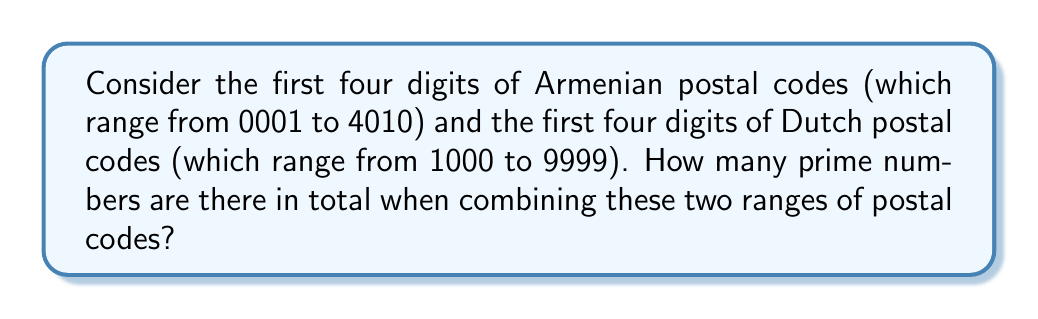Provide a solution to this math problem. Let's approach this step-by-step:

1) First, we need to identify the range of numbers we're considering:
   - Armenian postal codes: 0001 to 4010
   - Dutch postal codes: 1000 to 9999

2) We can combine these ranges into a single range: 0001 to 9999

3) Now, we need to count the prime numbers in this range. Let's use the Sieve of Eratosthenes method:

   a) Create a list of all numbers from 2 to 9999
   b) Starting with the first number (2), mark all its multiples as non-prime
   c) Move to the next unmarked number and repeat step b
   d) Continue until we've processed all numbers up to $\sqrt{9999} \approx 100$

4) After applying the Sieve of Eratosthenes, we count the unmarked numbers:

   $$\text{Prime count} = \pi(9999) - \pi(1) = 1229 - 0 = 1229$$

   Where $\pi(x)$ is the prime-counting function.

5) However, we need to exclude 0001 from our count as it's not a valid postal code:

   $$\text{Final count} = 1229 - 1 = 1228$$

Therefore, there are 1228 prime numbers in the combined range of Armenian and Dutch postal codes.
Answer: 1228 